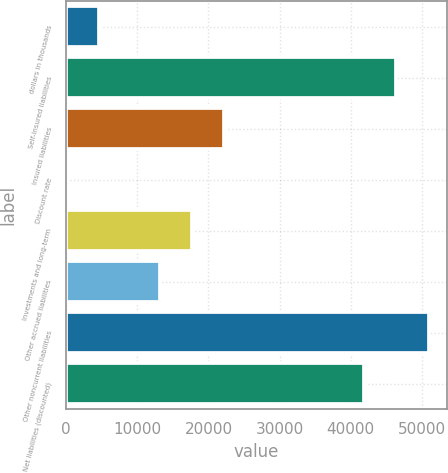Convert chart. <chart><loc_0><loc_0><loc_500><loc_500><bar_chart><fcel>dollars in thousands<fcel>Self-insured liabilities<fcel>Insured liabilities<fcel>Discount rate<fcel>Investments and long-term<fcel>Other accrued liabilities<fcel>Other noncurrent liabilities<fcel>Net liabilities (discounted)<nl><fcel>4558.06<fcel>46372.8<fcel>22244.5<fcel>1.29<fcel>17687.8<fcel>13131<fcel>50929.5<fcel>41816<nl></chart> 